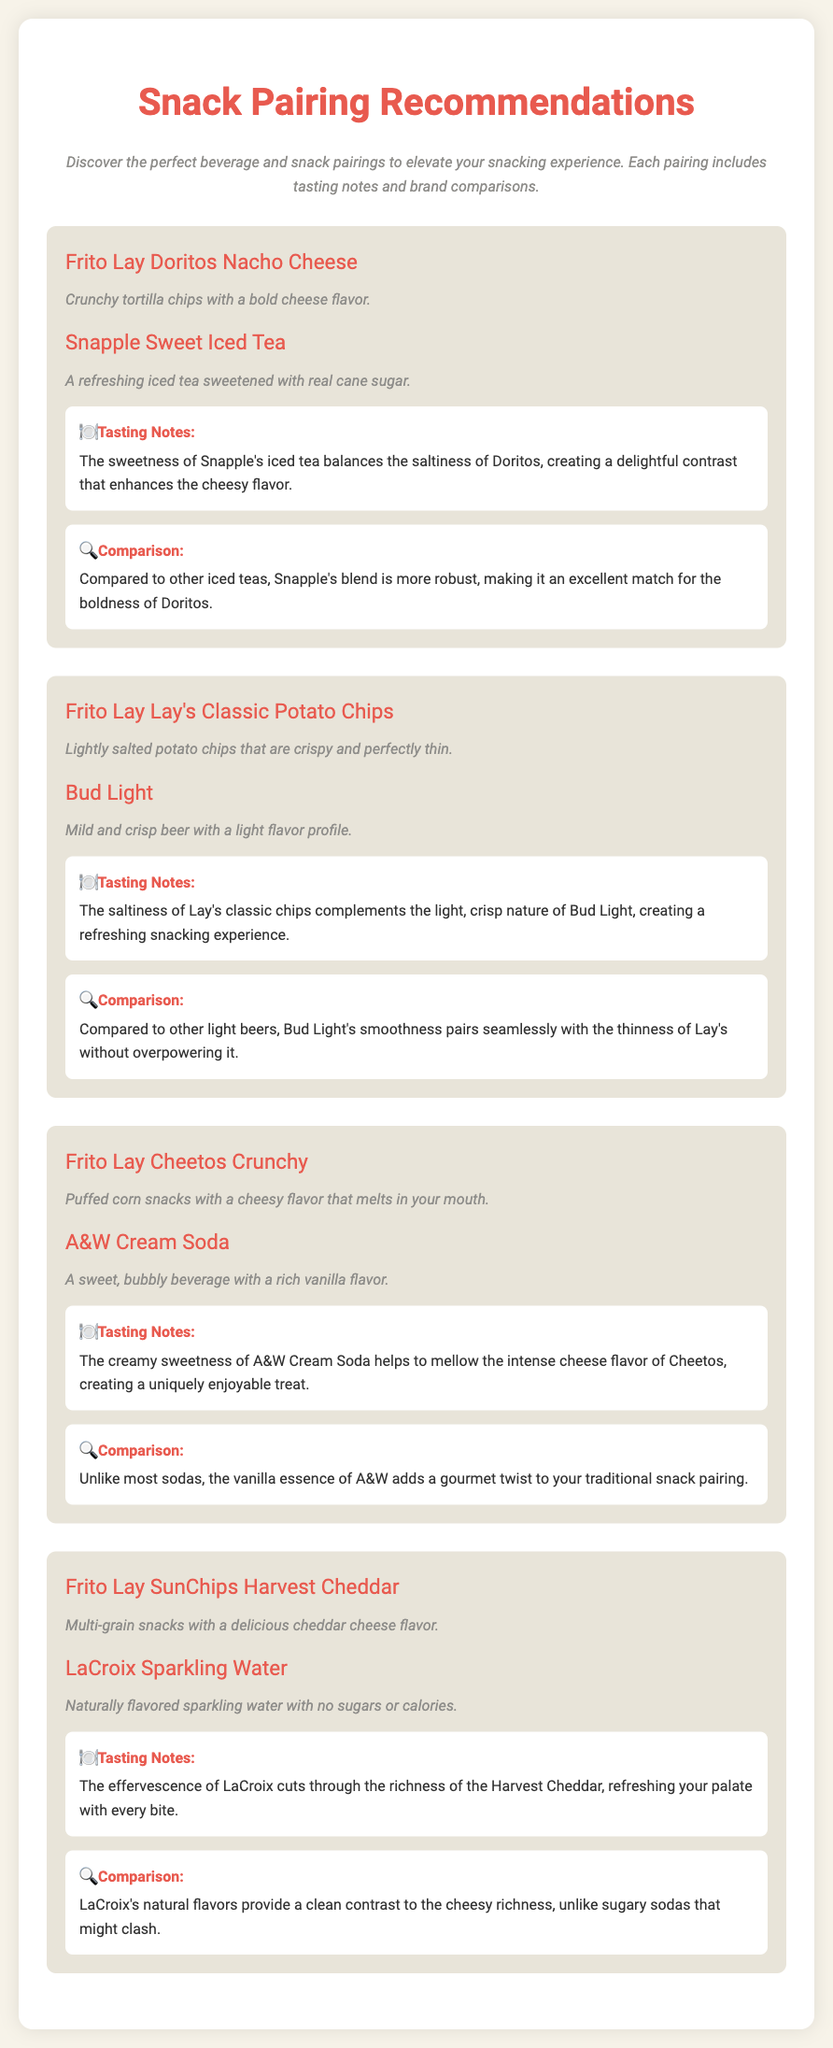What are the snacks listed? The document lists several snacks, including Frito Lay Doritos Nacho Cheese, Frito Lay Lay's Classic Potato Chips, Frito Lay Cheetos Crunchy, and Frito Lay SunChips Harvest Cheddar.
Answer: Doritos Nacho Cheese, Lay's Classic Potato Chips, Cheetos Crunchy, SunChips Harvest Cheddar What beverage is paired with Cheetos Crunchy? Each pairing includes a specific beverage, and for Cheetos Crunchy, it is A&W Cream Soda.
Answer: A&W Cream Soda What is the tasting note for Lay's Classic Potato Chips? The tasting note describes how the saltiness of Lay's classic chips complements the beer, creating a refreshing experience.
Answer: The saltiness of Lay's classic chips complements the light, crisp nature of Bud Light, creating a refreshing snacking experience Which beverage is described as having natural flavors? The beverage paired with the SunChips Harvest Cheddar snack is LaCroix Sparkling Water, which is noted for its natural flavors.
Answer: LaCroix Sparkling Water How does Snapple Sweet Iced Tea compare to other iced teas? The comparison states that Snapple's blend is more robust, making it an excellent match for the boldness of Doritos.
Answer: More robust What flavor profile does Bud Light have? The beverage's description indicates that Bud Light has a mild and crisp flavor profile.
Answer: Mild and crisp What snack has a cheesy flavor that melts in your mouth? The description for Cheetos Crunchy highlights their cheesy flavor and texture.
Answer: Cheetos Crunchy What is the primary characteristic of LaCroix Sparkling Water in this document? The document notes that LaCroix has no sugars or calories, emphasizing its uniqueness in contrast with sugary drinks.
Answer: No sugars or calories 